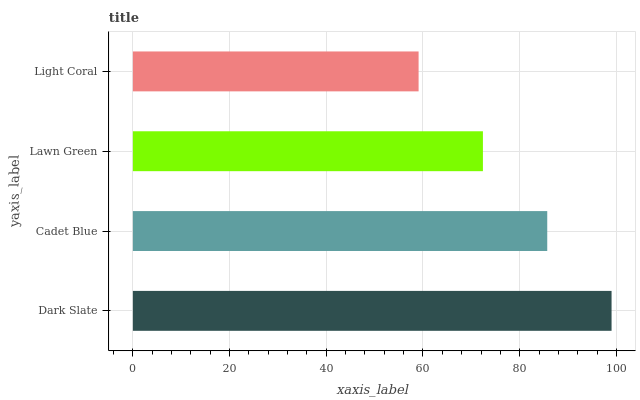Is Light Coral the minimum?
Answer yes or no. Yes. Is Dark Slate the maximum?
Answer yes or no. Yes. Is Cadet Blue the minimum?
Answer yes or no. No. Is Cadet Blue the maximum?
Answer yes or no. No. Is Dark Slate greater than Cadet Blue?
Answer yes or no. Yes. Is Cadet Blue less than Dark Slate?
Answer yes or no. Yes. Is Cadet Blue greater than Dark Slate?
Answer yes or no. No. Is Dark Slate less than Cadet Blue?
Answer yes or no. No. Is Cadet Blue the high median?
Answer yes or no. Yes. Is Lawn Green the low median?
Answer yes or no. Yes. Is Dark Slate the high median?
Answer yes or no. No. Is Dark Slate the low median?
Answer yes or no. No. 